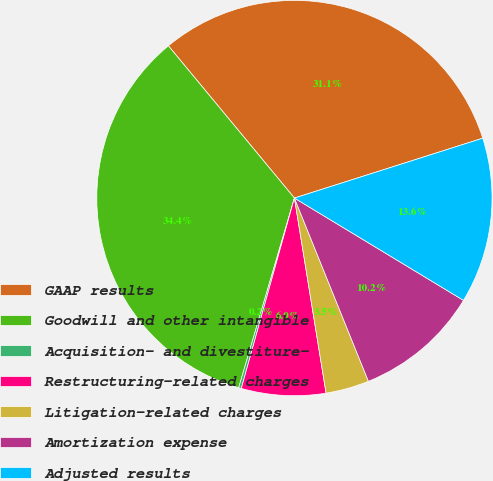Convert chart to OTSL. <chart><loc_0><loc_0><loc_500><loc_500><pie_chart><fcel>GAAP results<fcel>Goodwill and other intangible<fcel>Acquisition- and divestiture-<fcel>Restructuring-related charges<fcel>Litigation-related charges<fcel>Amortization expense<fcel>Adjusted results<nl><fcel>31.11%<fcel>34.45%<fcel>0.22%<fcel>6.89%<fcel>3.55%<fcel>10.23%<fcel>13.56%<nl></chart> 